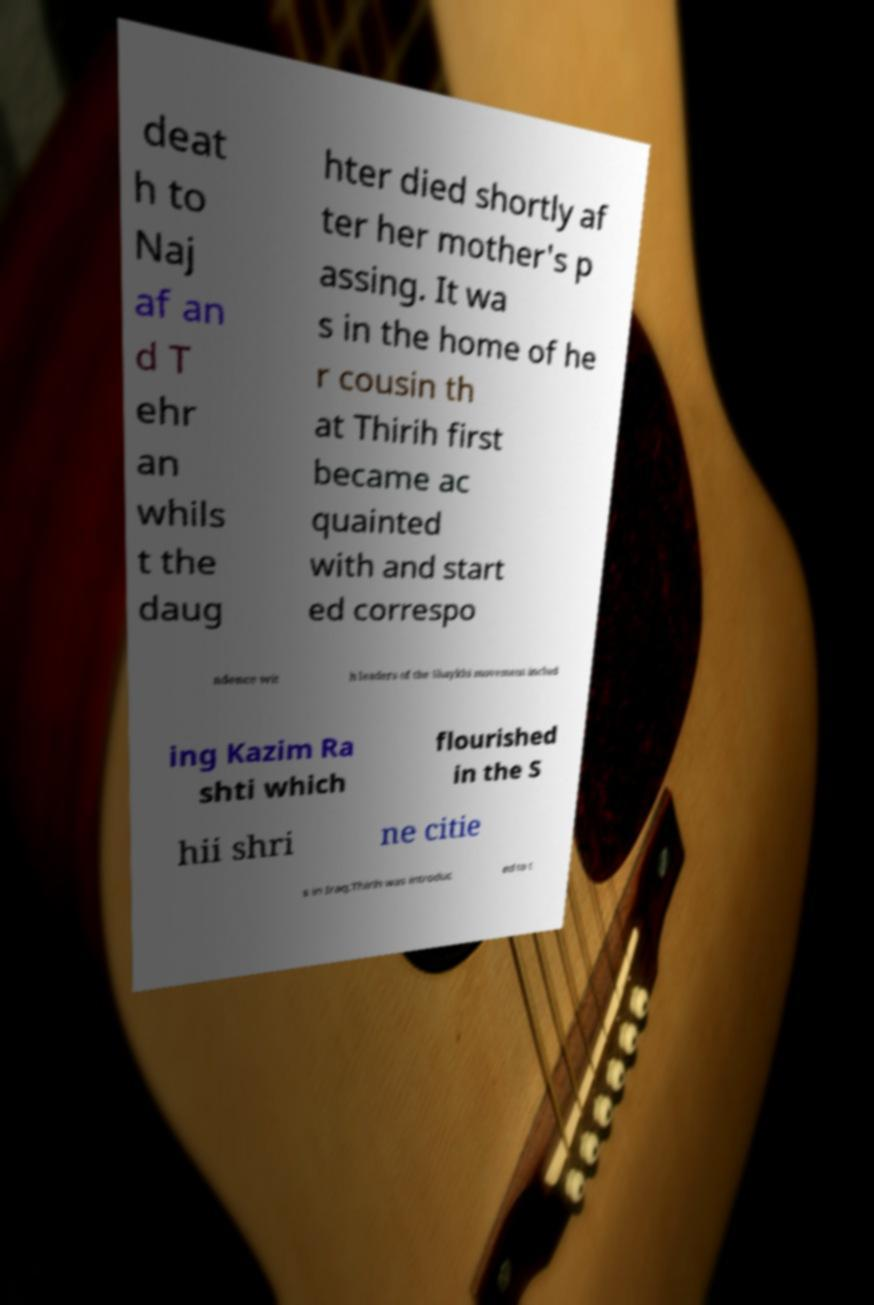Please read and relay the text visible in this image. What does it say? deat h to Naj af an d T ehr an whils t the daug hter died shortly af ter her mother's p assing. It wa s in the home of he r cousin th at Thirih first became ac quainted with and start ed correspo ndence wit h leaders of the Shaykhi movement includ ing Kazim Ra shti which flourished in the S hii shri ne citie s in Iraq.Thirih was introduc ed to t 